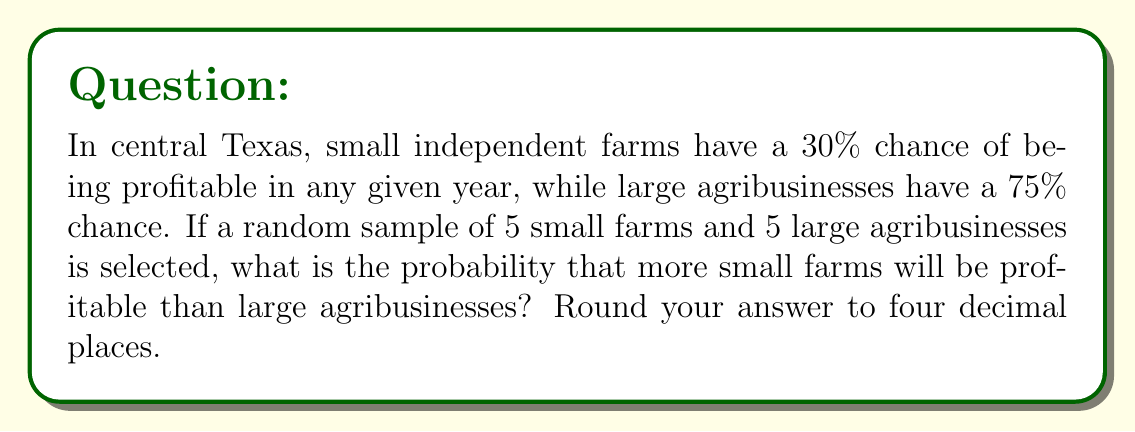Teach me how to tackle this problem. Let's approach this step-by-step:

1) First, we need to calculate the probability of each possible scenario where more small farms are profitable than large ones. This can happen in the following ways:
   - 5 small farms profitable, 0-4 large farms profitable
   - 4 small farms profitable, 0-3 large farms profitable
   - 3 small farms profitable, 0-2 large farms profitable

2) We can use the binomial probability formula for each of these scenarios:

   $$P(X = k) = \binom{n}{k} p^k (1-p)^{n-k}$$

   Where $n$ is the number of trials, $k$ is the number of successes, and $p$ is the probability of success.

3) Let's calculate each scenario:

   For small farms (S):
   $$P(S = 5) = \binom{5}{5} 0.3^5 (0.7)^0 = 0.00243$$
   $$P(S = 4) = \binom{5}{4} 0.3^4 (0.7)^1 = 0.02835$$
   $$P(S = 3) = \binom{5}{3} 0.3^3 (0.7)^2 = 0.13230$$

   For large farms (L):
   $$P(L = 0) = \binom{5}{0} 0.75^0 (0.25)^5 = 0.00098$$
   $$P(L = 1) = \binom{5}{1} 0.75^1 (0.25)^4 = 0.01465$$
   $$P(L = 2) = \binom{5}{2} 0.75^2 (0.25)^3 = 0.08789$$
   $$P(L = 3) = \binom{5}{3} 0.75^3 (0.25)^2 = 0.26367$$
   $$P(L = 4) = \binom{5}{4} 0.75^4 (0.25)^1 = 0.39551$$

4) Now, we sum up the probabilities of all favorable outcomes:

   $$P(\text{More S than L}) = P(S=5)(P(L=0) + P(L=1) + P(L=2) + P(L=3) + P(L=4))$$
   $$+ P(S=4)(P(L=0) + P(L=1) + P(L=2) + P(L=3))$$
   $$+ P(S=3)(P(L=0) + P(L=1) + P(L=2))$$

5) Plugging in the values:

   $$P(\text{More S than L}) = 0.00243(0.00098 + 0.01465 + 0.08789 + 0.26367 + 0.39551)$$
   $$+ 0.02835(0.00098 + 0.01465 + 0.08789 + 0.26367)$$
   $$+ 0.13230(0.00098 + 0.01465 + 0.08789)$$

6) Calculating:

   $$P(\text{More S than L}) = 0.00243(0.76270) + 0.02835(0.36719) + 0.13230(0.10352)$$
   $$= 0.00185 + 0.01041 + 0.01370 = 0.02596$$

7) Rounding to four decimal places: 0.0260
Answer: 0.0260 